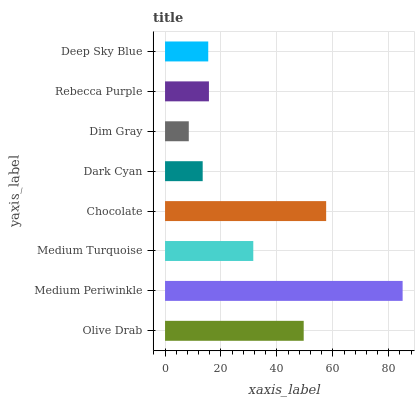Is Dim Gray the minimum?
Answer yes or no. Yes. Is Medium Periwinkle the maximum?
Answer yes or no. Yes. Is Medium Turquoise the minimum?
Answer yes or no. No. Is Medium Turquoise the maximum?
Answer yes or no. No. Is Medium Periwinkle greater than Medium Turquoise?
Answer yes or no. Yes. Is Medium Turquoise less than Medium Periwinkle?
Answer yes or no. Yes. Is Medium Turquoise greater than Medium Periwinkle?
Answer yes or no. No. Is Medium Periwinkle less than Medium Turquoise?
Answer yes or no. No. Is Medium Turquoise the high median?
Answer yes or no. Yes. Is Rebecca Purple the low median?
Answer yes or no. Yes. Is Deep Sky Blue the high median?
Answer yes or no. No. Is Deep Sky Blue the low median?
Answer yes or no. No. 